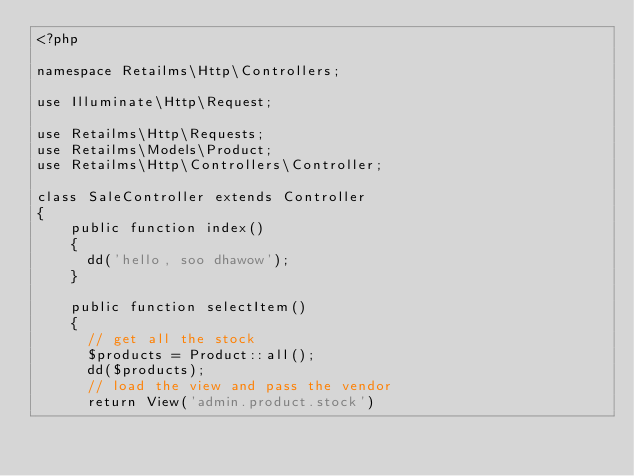Convert code to text. <code><loc_0><loc_0><loc_500><loc_500><_PHP_><?php

namespace Retailms\Http\Controllers;

use Illuminate\Http\Request;

use Retailms\Http\Requests;
use Retailms\Models\Product;
use Retailms\Http\Controllers\Controller;

class SaleController extends Controller
{
    public function index()
    {
    	dd('hello, soo dhawow');
    }

    public function selectItem()
    {
    	// get all the stock
    	$products = Product::all();
    	dd($products);
    	// load the view and pass the vendor
    	return View('admin.product.stock')</code> 